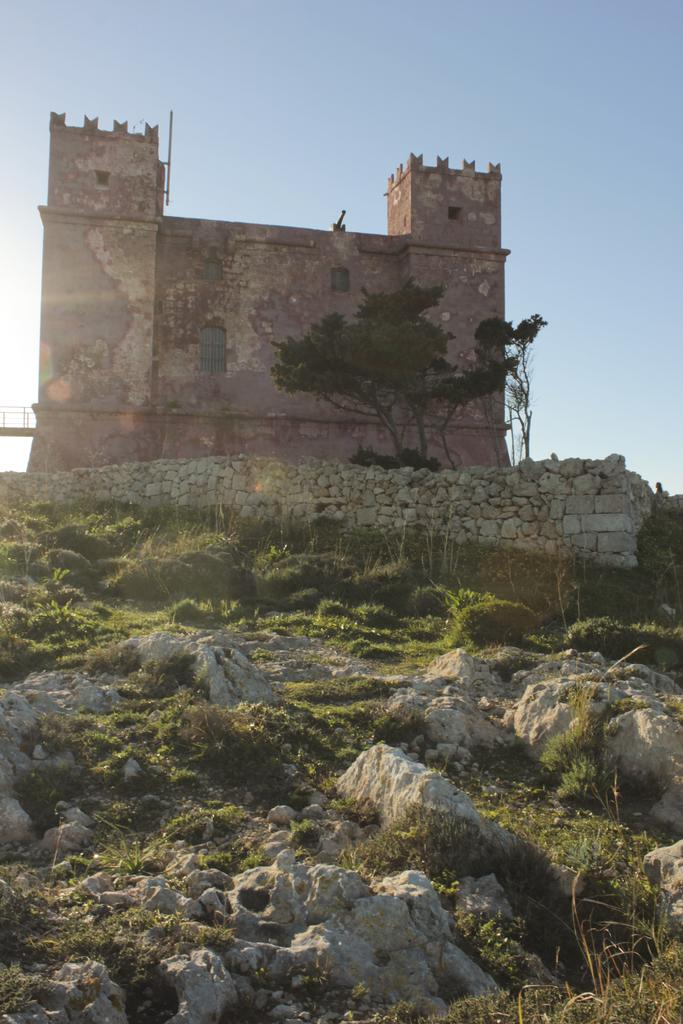What type of natural elements can be seen in the image? There are stones, grass, and bushes in the image. What type of structure is visible in the background of the image? There is a stone wall and a building in the background of the image. What type of vegetation can be seen in the background of the image? There are plants in the background of the image. What part of the natural environment is visible in the background of the image? The sky is visible in the background of the image. What type of ball is being used to play a game in the image? There is no ball present in the image; it features stones, grass, bushes, a stone wall, plants, a building, and the sky. 